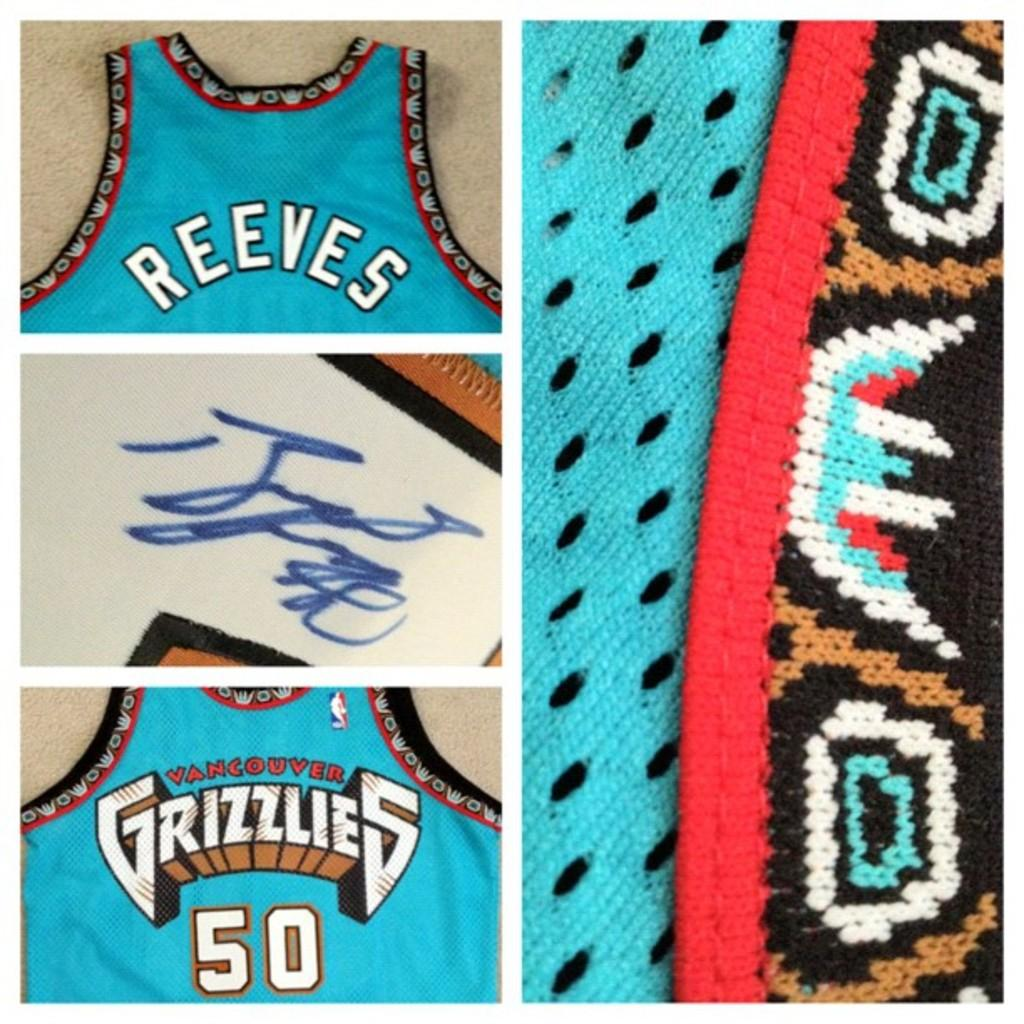<image>
Present a compact description of the photo's key features. a Grizzlies jersey that is blue and has the number 50 on it 